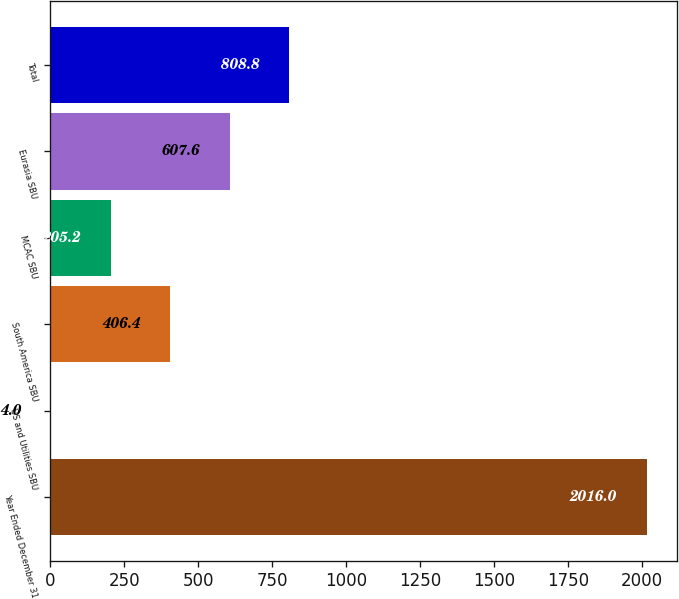Convert chart to OTSL. <chart><loc_0><loc_0><loc_500><loc_500><bar_chart><fcel>Year Ended December 31<fcel>US and Utilities SBU<fcel>South America SBU<fcel>MCAC SBU<fcel>Eurasia SBU<fcel>Total<nl><fcel>2016<fcel>4<fcel>406.4<fcel>205.2<fcel>607.6<fcel>808.8<nl></chart> 